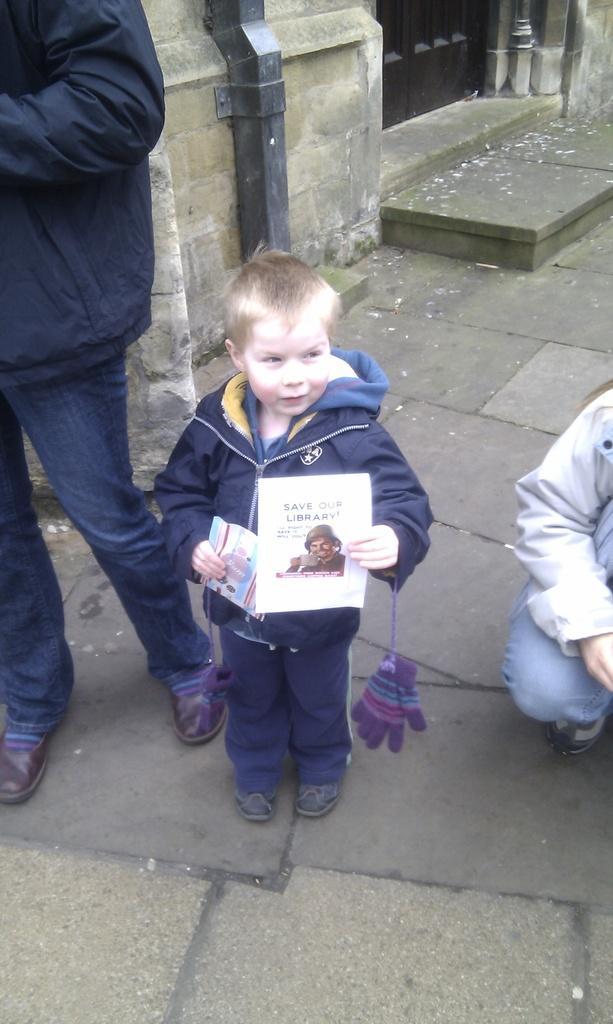Describe this image in one or two sentences. On the right side of the image we can see a person is standing and he wore a black color coat and blue color jeans. In the middle of the image we can see a boy holding a pamphlet in his hands and gloves are hanged to his hands. On the left side of the image we can see a person sitting on the floor. 